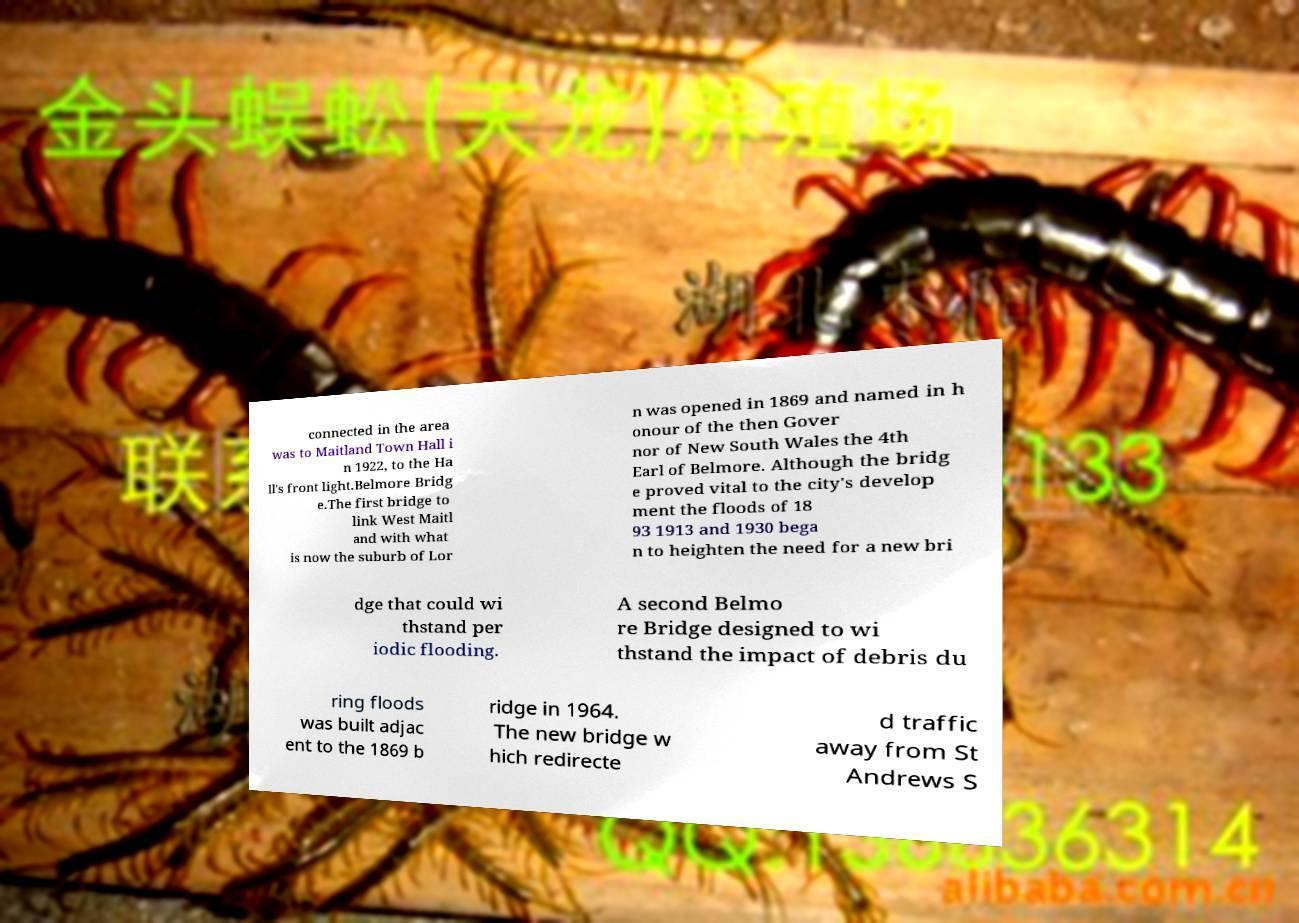Could you extract and type out the text from this image? connected in the area was to Maitland Town Hall i n 1922, to the Ha ll's front light.Belmore Bridg e.The first bridge to link West Maitl and with what is now the suburb of Lor n was opened in 1869 and named in h onour of the then Gover nor of New South Wales the 4th Earl of Belmore. Although the bridg e proved vital to the city's develop ment the floods of 18 93 1913 and 1930 bega n to heighten the need for a new bri dge that could wi thstand per iodic flooding. A second Belmo re Bridge designed to wi thstand the impact of debris du ring floods was built adjac ent to the 1869 b ridge in 1964. The new bridge w hich redirecte d traffic away from St Andrews S 